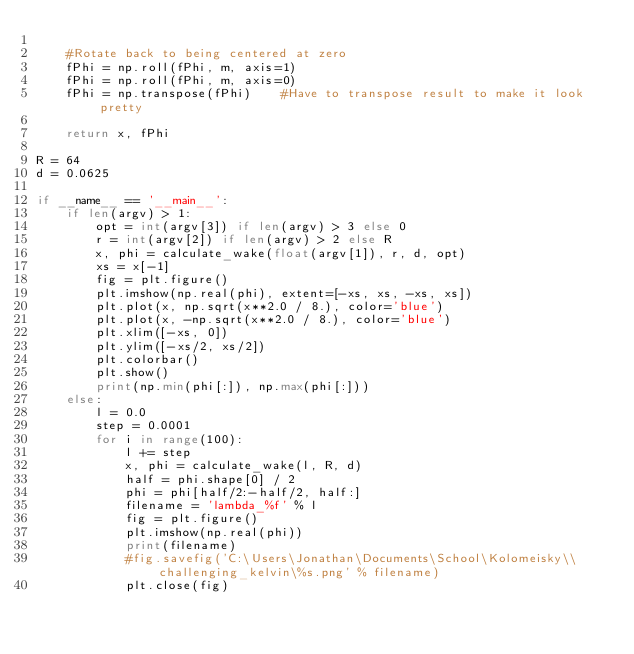<code> <loc_0><loc_0><loc_500><loc_500><_Python_>
    #Rotate back to being centered at zero
    fPhi = np.roll(fPhi, m, axis=1)
    fPhi = np.roll(fPhi, m, axis=0)
    fPhi = np.transpose(fPhi)    #Have to transpose result to make it look pretty
    
    return x, fPhi
    
R = 64
d = 0.0625

if __name__ == '__main__':
    if len(argv) > 1:
        opt = int(argv[3]) if len(argv) > 3 else 0
        r = int(argv[2]) if len(argv) > 2 else R
        x, phi = calculate_wake(float(argv[1]), r, d, opt)
        xs = x[-1]
        fig = plt.figure()
        plt.imshow(np.real(phi), extent=[-xs, xs, -xs, xs])
        plt.plot(x, np.sqrt(x**2.0 / 8.), color='blue')
        plt.plot(x, -np.sqrt(x**2.0 / 8.), color='blue')
        plt.xlim([-xs, 0])
        plt.ylim([-xs/2, xs/2])
        plt.colorbar()
        plt.show()
        print(np.min(phi[:]), np.max(phi[:]))
    else:
        l = 0.0
        step = 0.0001
        for i in range(100):
            l += step
            x, phi = calculate_wake(l, R, d)
            half = phi.shape[0] / 2
            phi = phi[half/2:-half/2, half:]
            filename = 'lambda_%f' % l
            fig = plt.figure()
            plt.imshow(np.real(phi))
            print(filename)
            #fig.savefig('C:\Users\Jonathan\Documents\School\Kolomeisky\\challenging_kelvin\%s.png' % filename)
            plt.close(fig)
</code> 